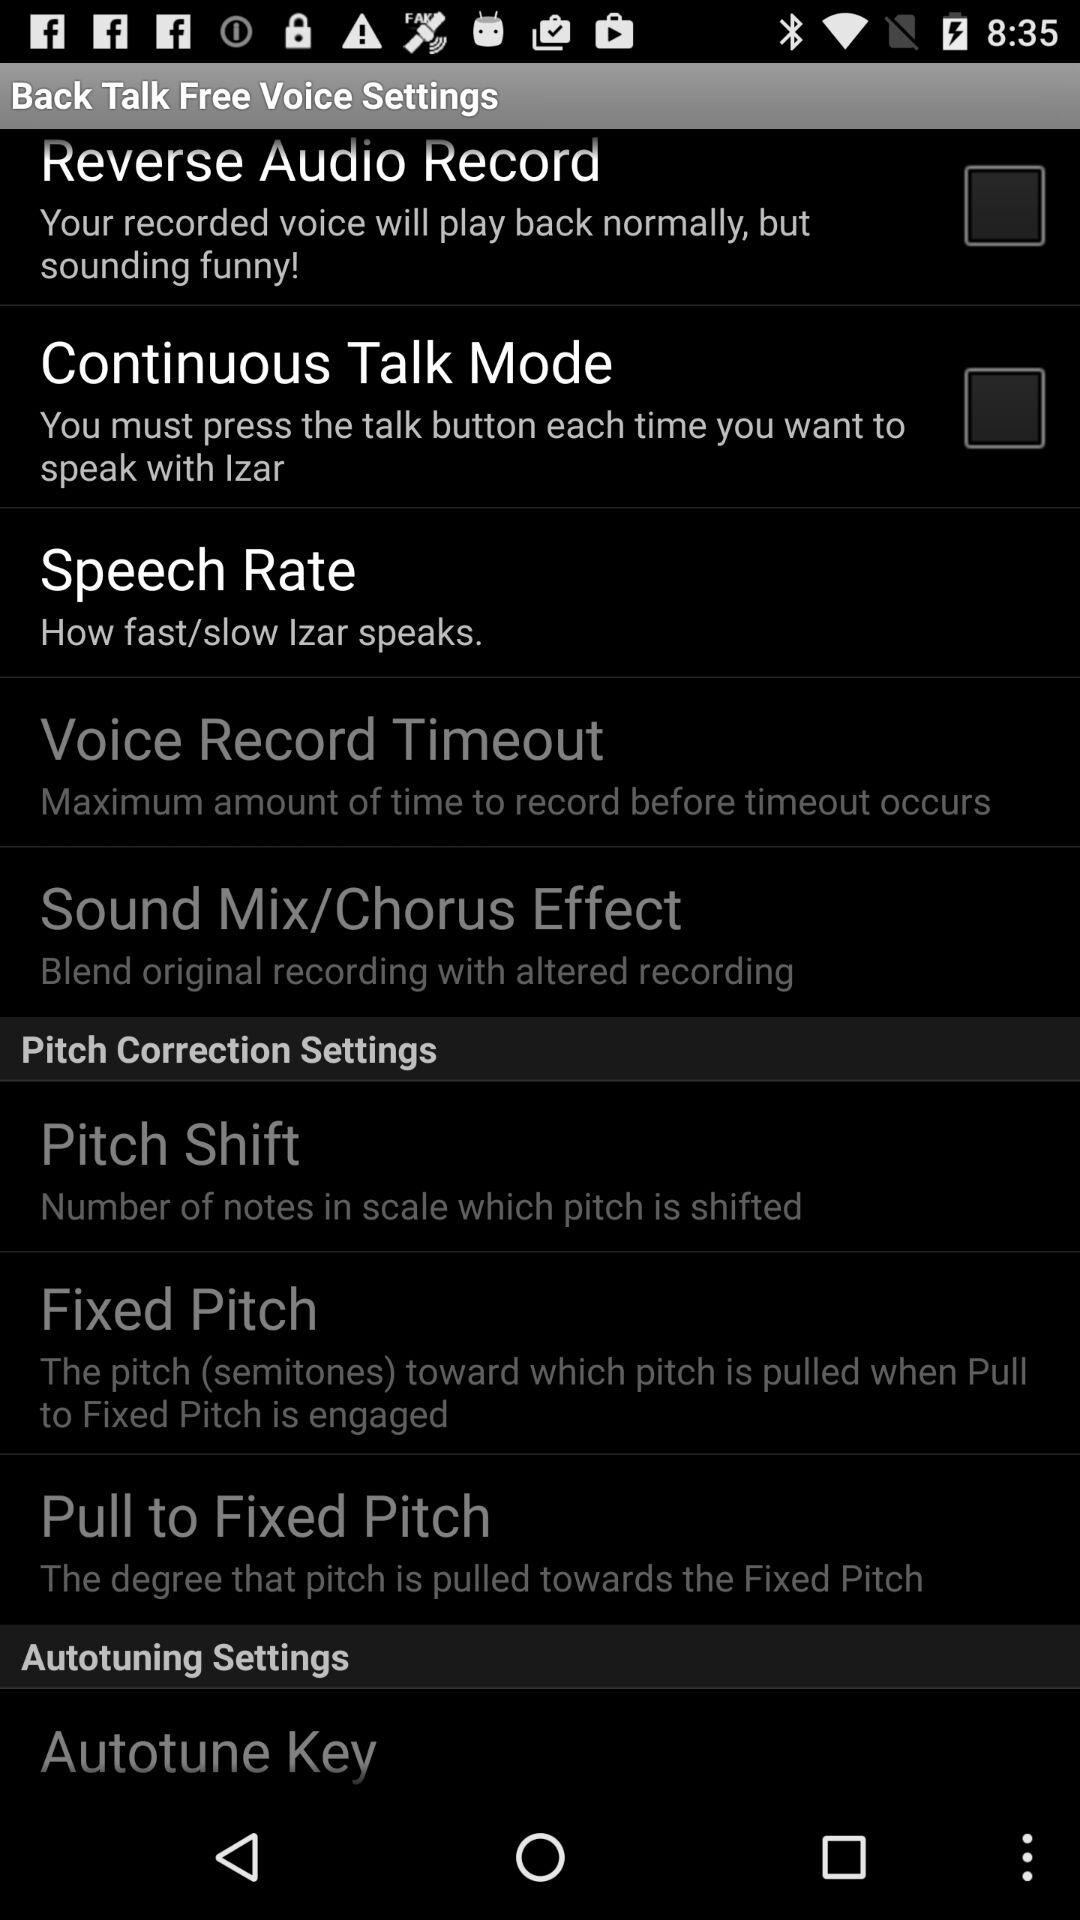How many pitch correction settings are there?
Answer the question using a single word or phrase. 3 